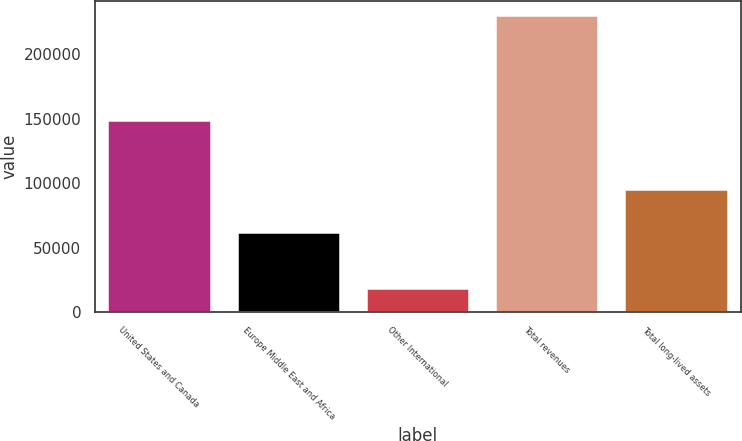Convert chart to OTSL. <chart><loc_0><loc_0><loc_500><loc_500><bar_chart><fcel>United States and Canada<fcel>Europe Middle East and Africa<fcel>Other International<fcel>Total revenues<fcel>Total long-lived assets<nl><fcel>148585<fcel>62412<fcel>18817<fcel>229814<fcel>95719<nl></chart> 